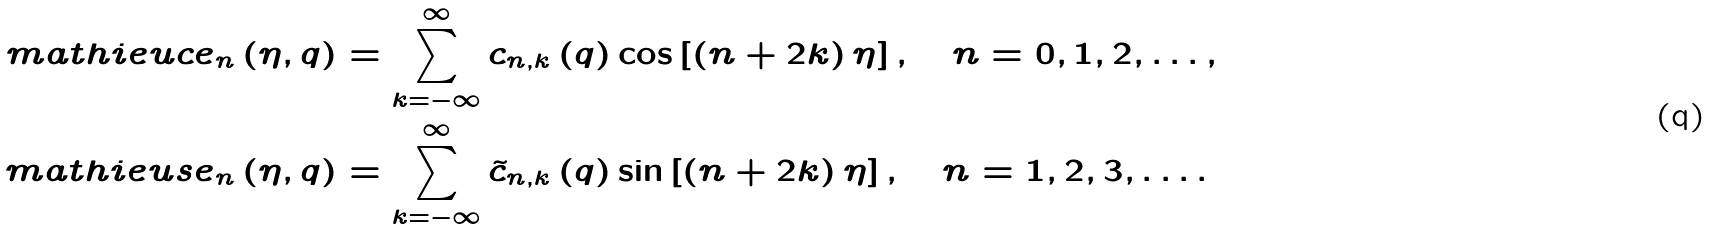<formula> <loc_0><loc_0><loc_500><loc_500>\ m a t h i e u c e _ { n } \left ( \eta , q \right ) & = \sum _ { k = - \infty } ^ { \infty } c _ { n , k } \left ( q \right ) \cos \left [ \left ( n + 2 k \right ) \eta \right ] , \quad n = 0 , 1 , 2 , \dots , \\ \ m a t h i e u s e _ { n } \left ( \eta , q \right ) & = \sum _ { k = - \infty } ^ { \infty } \tilde { c } _ { n , k } \left ( q \right ) \sin \left [ \left ( n + 2 k \right ) \eta \right ] , \quad n = 1 , 2 , 3 , \dots .</formula> 